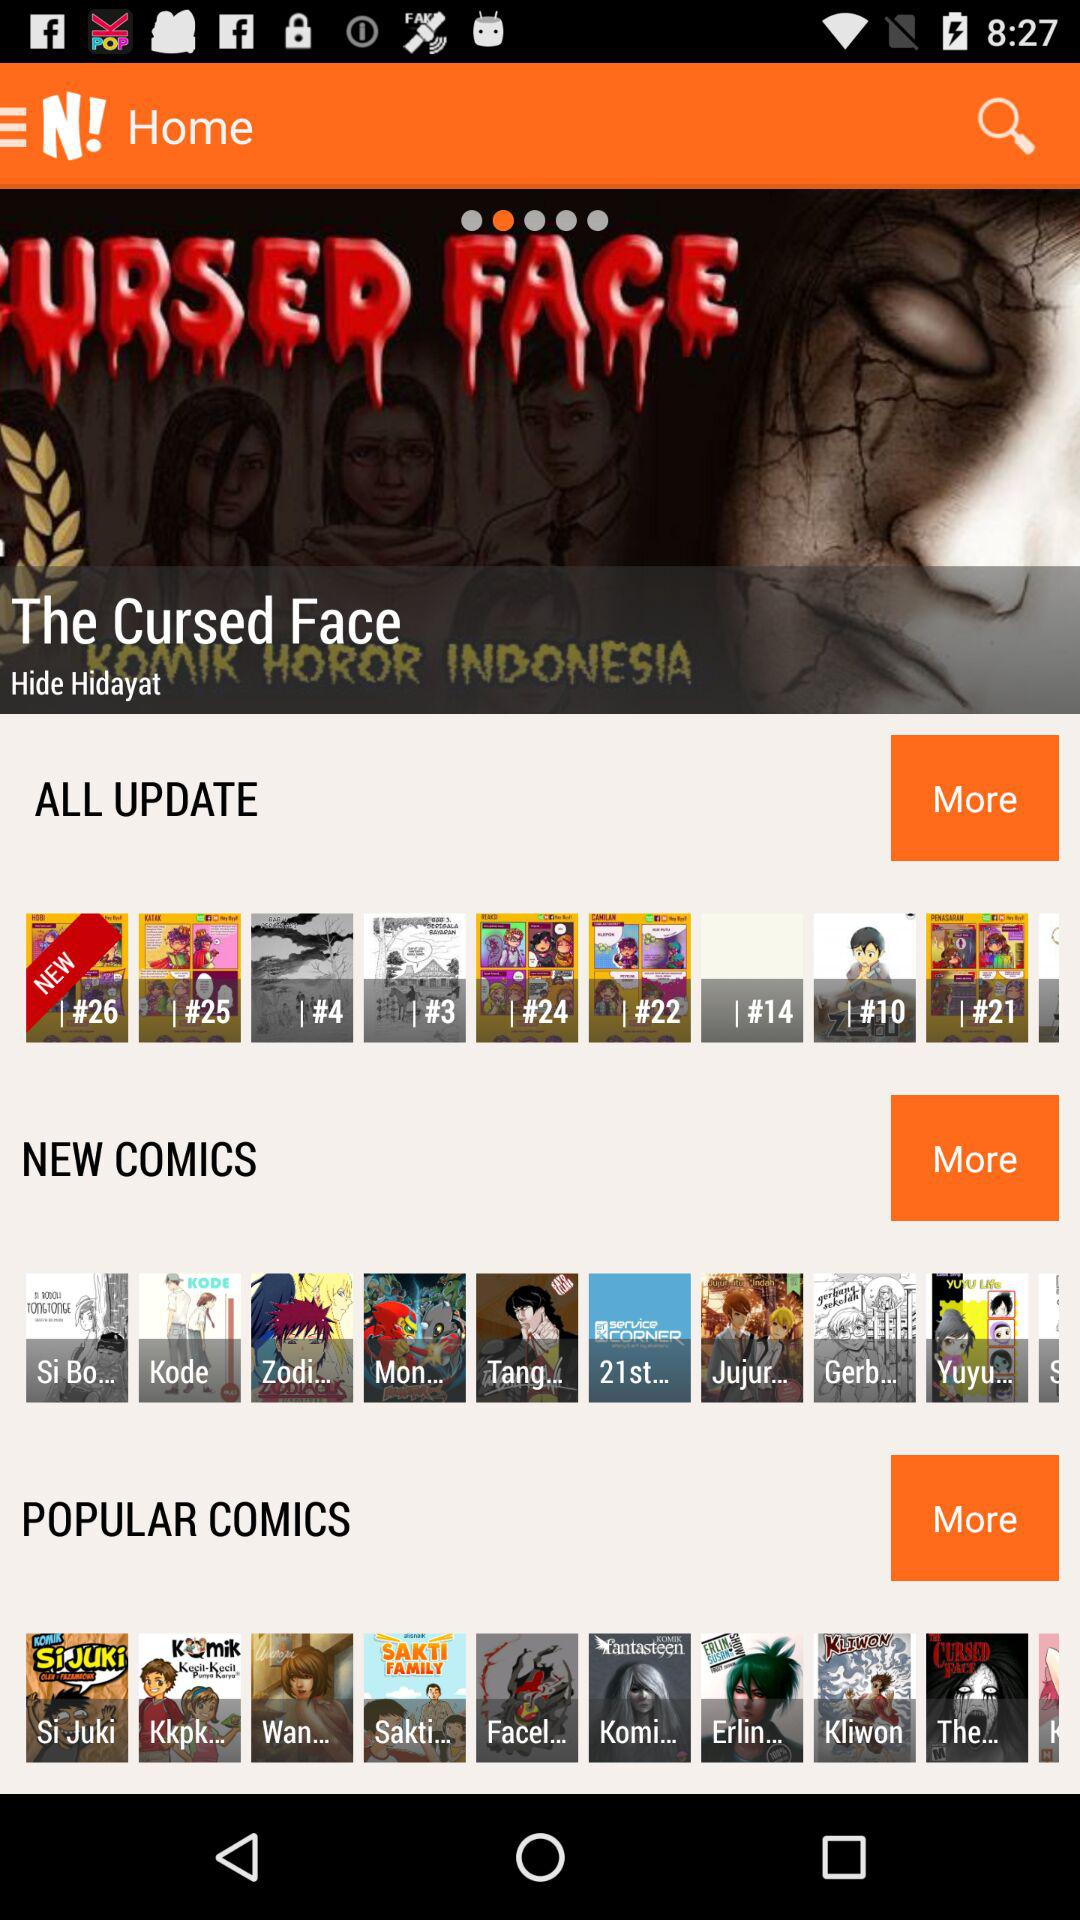What is the name of the comic? The name of the comic is "The Cursed Face". 